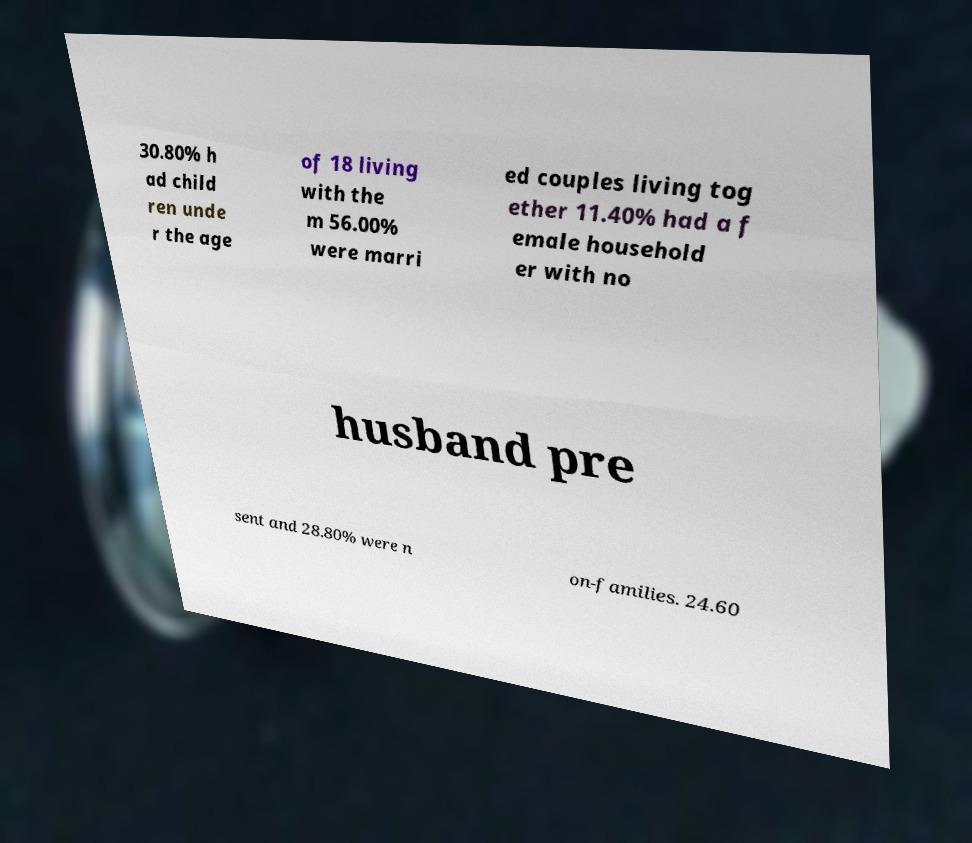What messages or text are displayed in this image? I need them in a readable, typed format. 30.80% h ad child ren unde r the age of 18 living with the m 56.00% were marri ed couples living tog ether 11.40% had a f emale household er with no husband pre sent and 28.80% were n on-families. 24.60 